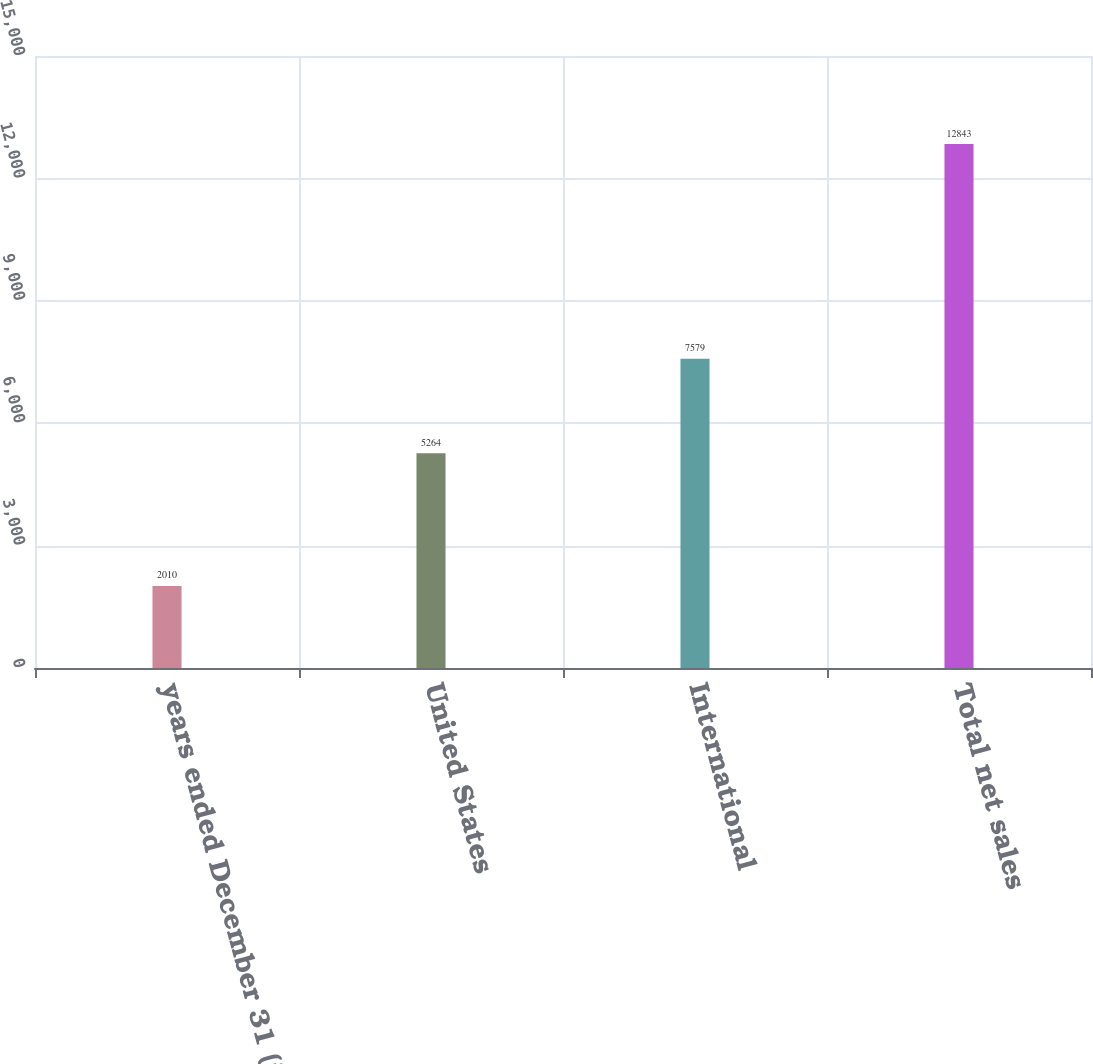Convert chart to OTSL. <chart><loc_0><loc_0><loc_500><loc_500><bar_chart><fcel>years ended December 31 (in<fcel>United States<fcel>International<fcel>Total net sales<nl><fcel>2010<fcel>5264<fcel>7579<fcel>12843<nl></chart> 